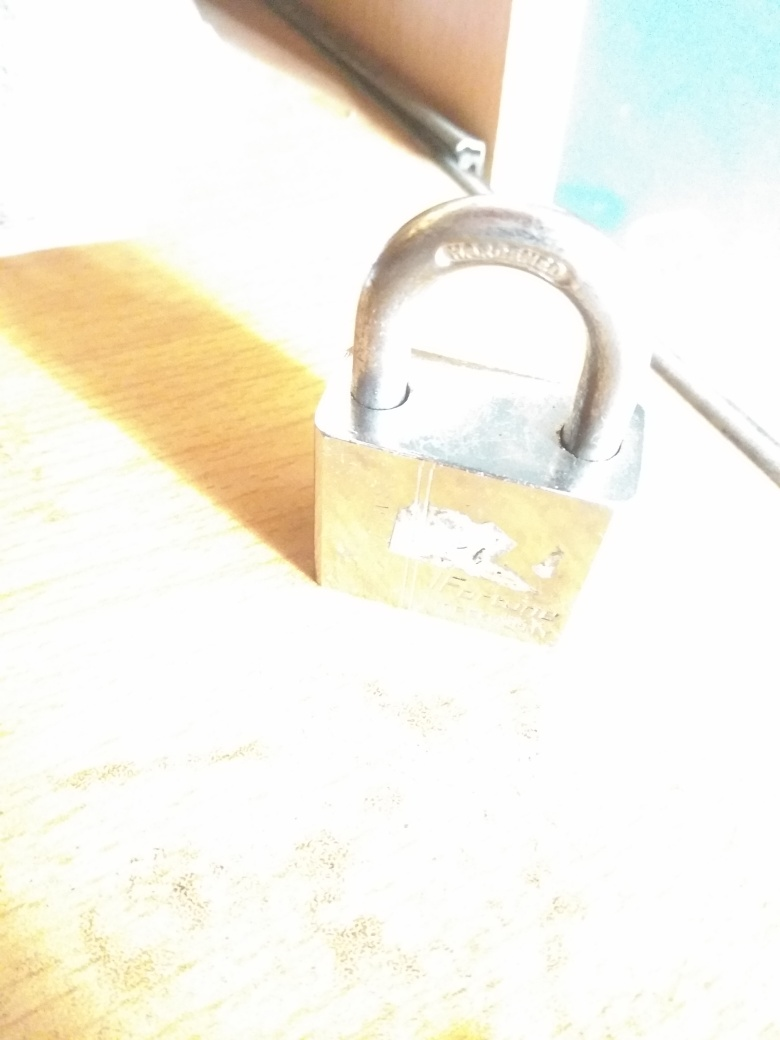Can you provide some tips for photographing metallic objects? When photographing metallic objects, it's important to control reflections and highlights since metal surfaces can easily catch and reflect light. Use diffused lighting, play with angles to avoid direct light hitting the surface, and consider using a polarizing filter to minimize glare. For better detailing, ensure the camera's focus is set to capture the texture and features of the metal. 